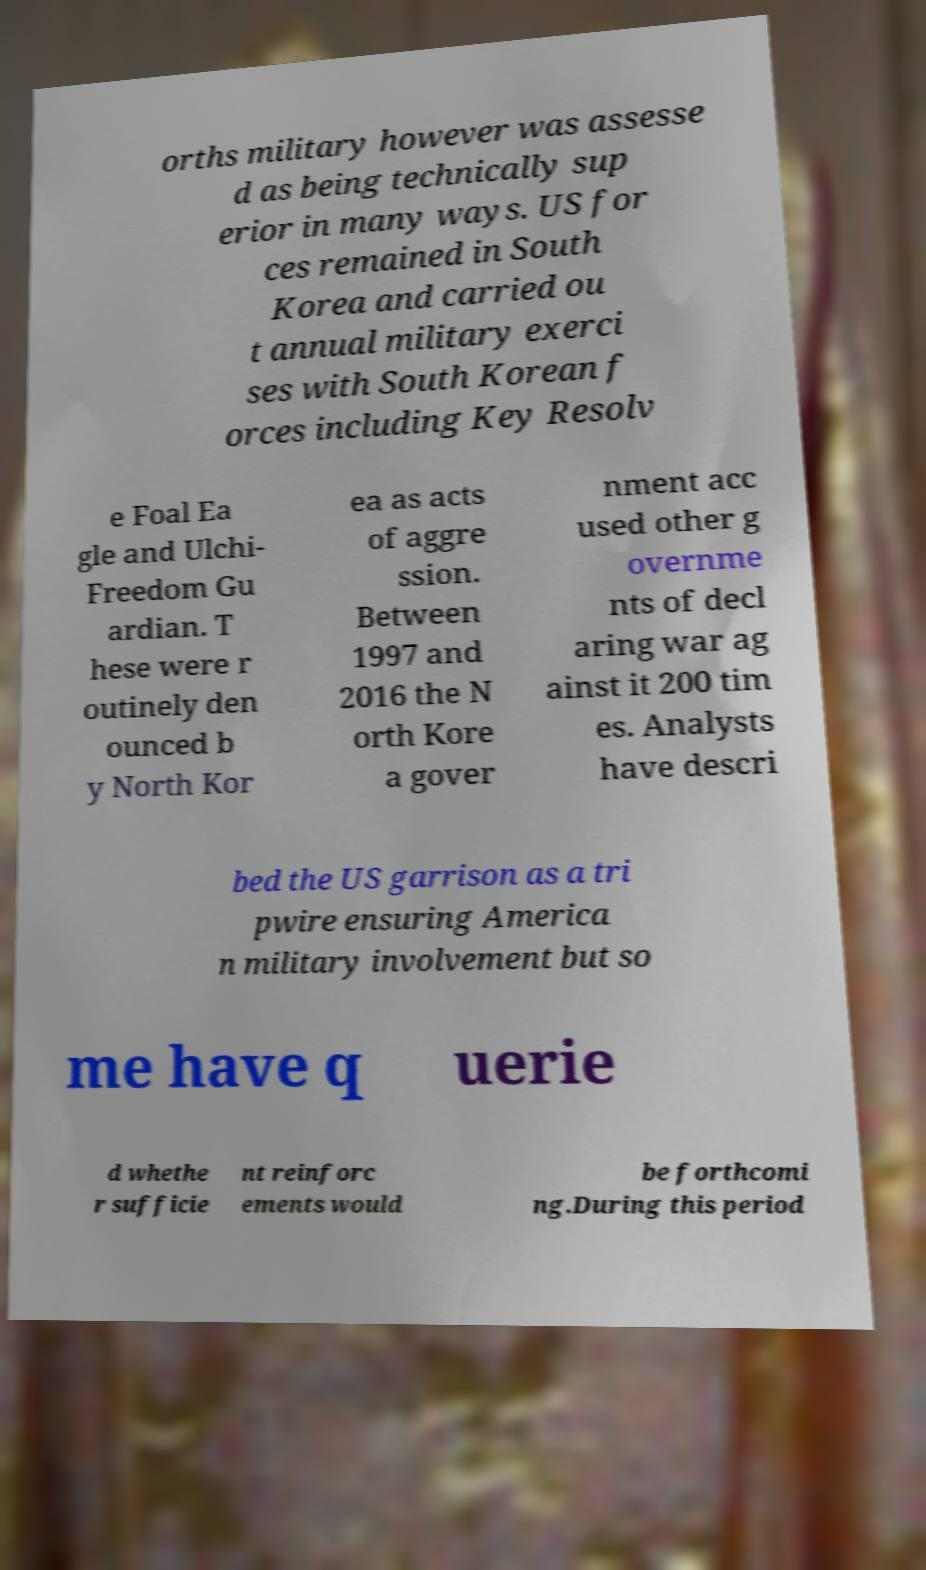Could you assist in decoding the text presented in this image and type it out clearly? orths military however was assesse d as being technically sup erior in many ways. US for ces remained in South Korea and carried ou t annual military exerci ses with South Korean f orces including Key Resolv e Foal Ea gle and Ulchi- Freedom Gu ardian. T hese were r outinely den ounced b y North Kor ea as acts of aggre ssion. Between 1997 and 2016 the N orth Kore a gover nment acc used other g overnme nts of decl aring war ag ainst it 200 tim es. Analysts have descri bed the US garrison as a tri pwire ensuring America n military involvement but so me have q uerie d whethe r sufficie nt reinforc ements would be forthcomi ng.During this period 